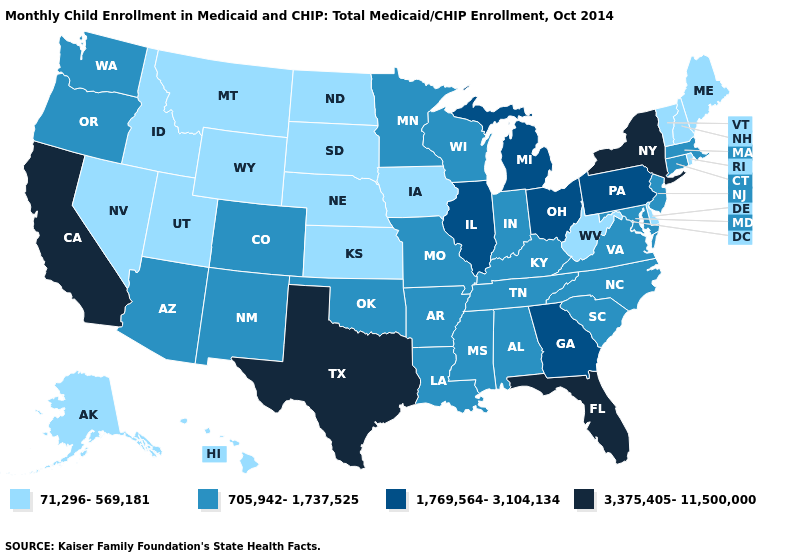What is the lowest value in the Northeast?
Answer briefly. 71,296-569,181. What is the value of Idaho?
Write a very short answer. 71,296-569,181. Name the states that have a value in the range 71,296-569,181?
Give a very brief answer. Alaska, Delaware, Hawaii, Idaho, Iowa, Kansas, Maine, Montana, Nebraska, Nevada, New Hampshire, North Dakota, Rhode Island, South Dakota, Utah, Vermont, West Virginia, Wyoming. Name the states that have a value in the range 71,296-569,181?
Give a very brief answer. Alaska, Delaware, Hawaii, Idaho, Iowa, Kansas, Maine, Montana, Nebraska, Nevada, New Hampshire, North Dakota, Rhode Island, South Dakota, Utah, Vermont, West Virginia, Wyoming. Does the map have missing data?
Answer briefly. No. Name the states that have a value in the range 1,769,564-3,104,134?
Keep it brief. Georgia, Illinois, Michigan, Ohio, Pennsylvania. Which states have the lowest value in the Northeast?
Be succinct. Maine, New Hampshire, Rhode Island, Vermont. Name the states that have a value in the range 3,375,405-11,500,000?
Keep it brief. California, Florida, New York, Texas. Does Colorado have a higher value than Utah?
Answer briefly. Yes. Does South Carolina have a lower value than Texas?
Answer briefly. Yes. Does the map have missing data?
Keep it brief. No. Name the states that have a value in the range 3,375,405-11,500,000?
Short answer required. California, Florida, New York, Texas. Is the legend a continuous bar?
Quick response, please. No. Which states have the lowest value in the MidWest?
Short answer required. Iowa, Kansas, Nebraska, North Dakota, South Dakota. Which states have the lowest value in the South?
Concise answer only. Delaware, West Virginia. 